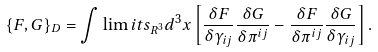<formula> <loc_0><loc_0><loc_500><loc_500>\{ F , G \} _ { D } = \int \lim i t s _ { R ^ { 3 } } d ^ { 3 } x \left [ \frac { \delta F } { \delta \gamma _ { i j } } \frac { \delta G } { \delta \pi ^ { i j } } - \frac { \delta F } { \delta \pi ^ { i j } } \frac { \delta G } { \delta \gamma _ { i j } } \right ] .</formula> 